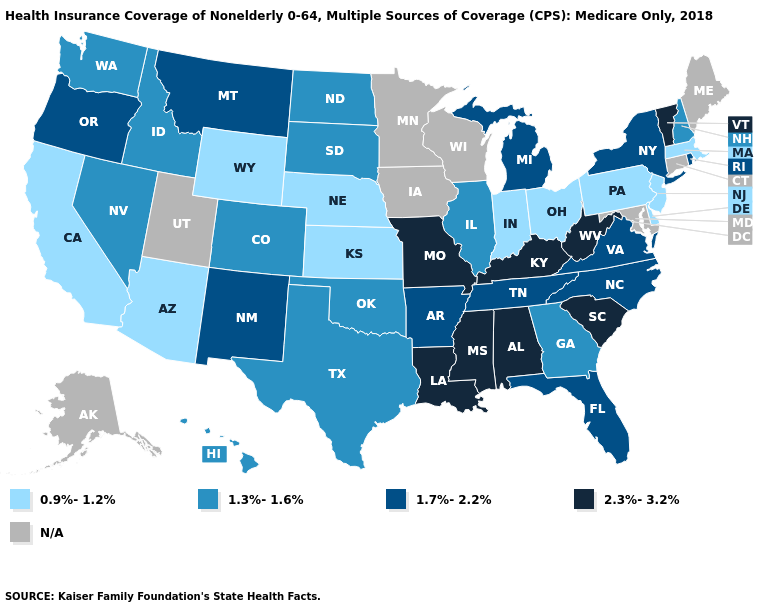What is the value of California?
Concise answer only. 0.9%-1.2%. What is the value of Massachusetts?
Write a very short answer. 0.9%-1.2%. Does the map have missing data?
Concise answer only. Yes. Which states hav the highest value in the Northeast?
Concise answer only. Vermont. What is the value of Hawaii?
Quick response, please. 1.3%-1.6%. What is the value of Louisiana?
Quick response, please. 2.3%-3.2%. Name the states that have a value in the range N/A?
Answer briefly. Alaska, Connecticut, Iowa, Maine, Maryland, Minnesota, Utah, Wisconsin. What is the value of Pennsylvania?
Be succinct. 0.9%-1.2%. What is the value of Nebraska?
Quick response, please. 0.9%-1.2%. What is the value of Maryland?
Be succinct. N/A. Name the states that have a value in the range 1.3%-1.6%?
Quick response, please. Colorado, Georgia, Hawaii, Idaho, Illinois, Nevada, New Hampshire, North Dakota, Oklahoma, South Dakota, Texas, Washington. Which states have the lowest value in the West?
Keep it brief. Arizona, California, Wyoming. Does the map have missing data?
Write a very short answer. Yes. Which states have the lowest value in the USA?
Keep it brief. Arizona, California, Delaware, Indiana, Kansas, Massachusetts, Nebraska, New Jersey, Ohio, Pennsylvania, Wyoming. 